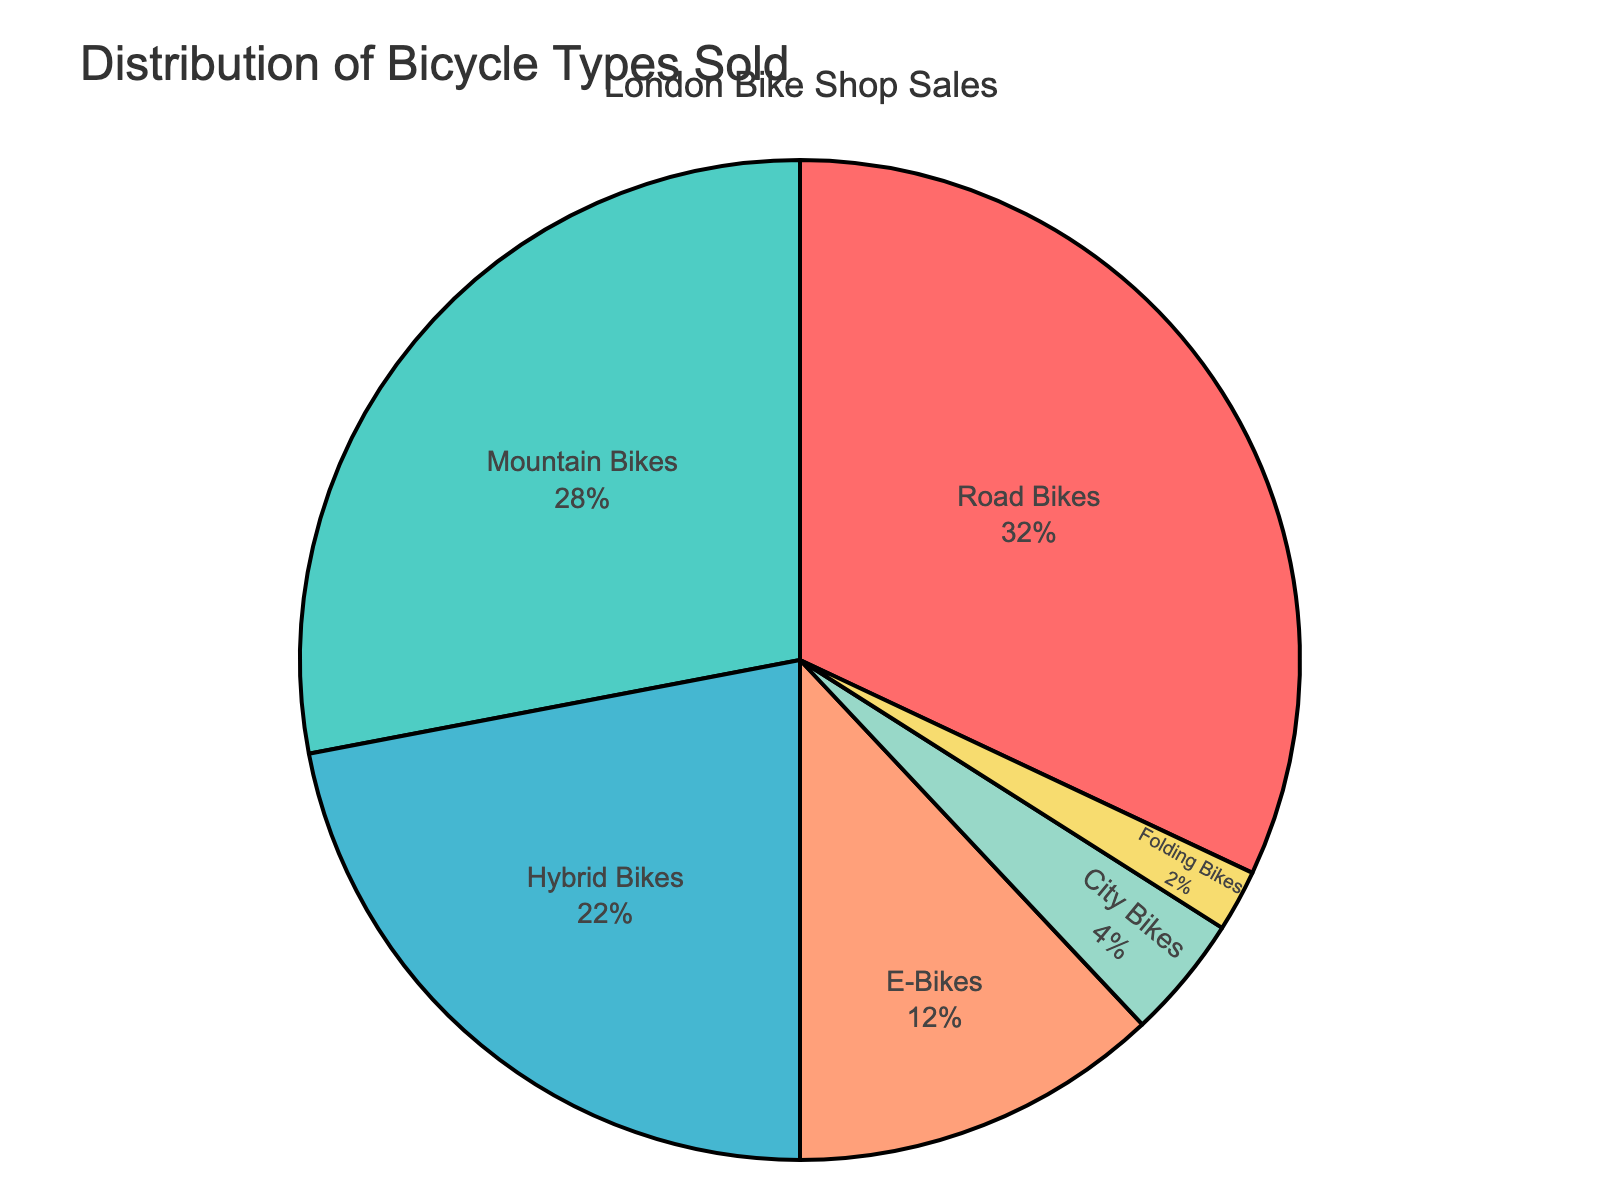Which type of bicycle is sold the most? The pie chart shows the slices for each bicycle type. The largest slice represents Road Bikes at 32%.
Answer: Road Bikes Which bicycle types together make up more than half of the sales? Adding the percentages of the largest slices, Road Bikes (32%) and Mountain Bikes (28%) gives 60%, which is more than half.
Answer: Road Bikes and Mountain Bikes Which bicycle type is sold the least? The smallest slice in the pie chart represents Folding Bikes at 2%.
Answer: Folding Bikes Are more Hybrid Bikes sold compared to E-Bikes? The slice for Hybrid Bikes is larger than that for E-Bikes. Hybrid Bikes account for 22% while E-Bikes account for 12%.
Answer: Yes Compare the sales percentage of City Bikes and Folding Bikes. The pie chart shows City Bikes at 4% and Folding Bikes at 2%. Therefore, City Bikes have a greater percentage than Folding Bikes.
Answer: City Bikes have a greater percentage than Folding Bikes What is the percentage difference between sales of Mountain Bikes and Hybrid Bikes? Subtracting the percentage of Hybrid Bikes (22%) from Mountain Bikes (28%) gives a difference of 6%.
Answer: 6% What proportion of sales is made up by bicycles other than Road and Mountain Bikes? Adding the percentages for Hybrid Bikes (22%), E-Bikes (12%), City Bikes (4%), and Folding Bikes (2%) gives 40%.
Answer: 40% How much greater are the sales of Road Bikes compared to E-Bikes? Subtracting the percentage of E-Bikes (12%) from Road Bikes (32%) gives a difference of 20%.
Answer: 20% If you combined the sales of Hybrid Bikes and City Bikes, would they surpass the sales of Road Bikes? Adding the percentages of Hybrid Bikes (22%) and City Bikes (4%) gives us 26%, which is less than the 32% of Road Bikes.
Answer: No What is the average sales percentage of Mountain Bikes, City Bikes, and E-Bikes? Adding the percentages of Mountain Bikes (28%), City Bikes (4%), and E-Bikes (12%) gives 44%. Dividing 44% by 3 gives an average of 14.67%.
Answer: 14.67% 